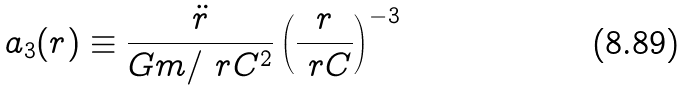Convert formula to latex. <formula><loc_0><loc_0><loc_500><loc_500>a _ { 3 } ( r ) \equiv \frac { \ddot { r } } { G m / \ r C ^ { 2 } } \left ( \frac { r } { \ r C } \right ) ^ { - 3 }</formula> 